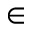Convert formula to latex. <formula><loc_0><loc_0><loc_500><loc_500>\in</formula> 